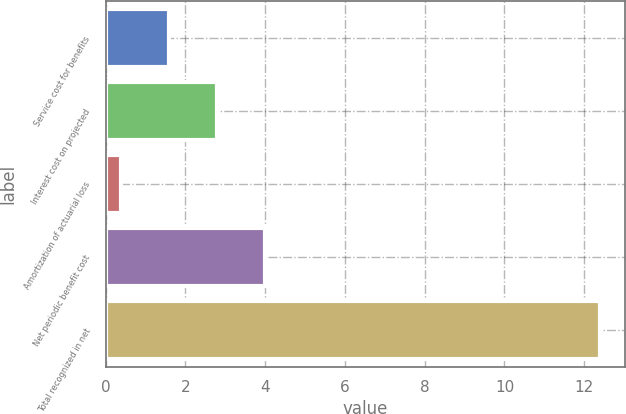Convert chart. <chart><loc_0><loc_0><loc_500><loc_500><bar_chart><fcel>Service cost for benefits<fcel>Interest cost on projected<fcel>Amortization of actuarial loss<fcel>Net periodic benefit cost<fcel>Total recognized in net<nl><fcel>1.6<fcel>2.8<fcel>0.4<fcel>4<fcel>12.4<nl></chart> 